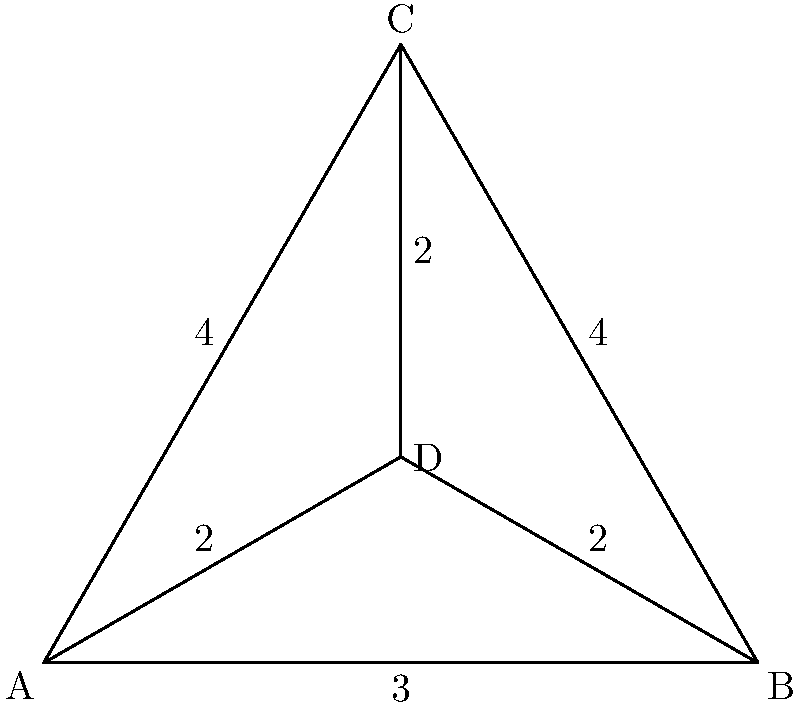As a patrol commander, you need to determine the most efficient route that covers all checkpoints in your area of responsibility. The diagram shows the network of checkpoints and the distances between them. What is the length of the shortest path that visits all checkpoints exactly once and returns to the starting point? To solve this problem, we need to find the Hamiltonian cycle with the shortest total length. This is known as the Traveling Salesman Problem. Let's approach this step-by-step:

1. Identify all possible Hamiltonian cycles:
   ABCDA, ACBDA, ABDCA, ACDBA, ADCBA, ADBCA

2. Calculate the length of each cycle:
   ABCDA: 3 + 4 + 2 + 2 = 11
   ACBDA: 4 + 4 + 2 + 2 = 12
   ABDCA: 3 + 2 + 2 + 4 = 11
   ACDBA: 4 + 2 + 2 + 3 = 11
   ADCBA: 2 + 2 + 4 + 3 = 11
   ADBCA: 2 + 2 + 4 + 4 = 12

3. Identify the shortest cycle(s):
   ABCDA, ABDCA, ACDBA, and ADCBA all have a length of 11, which is the shortest possible.

4. Verify that no shorter path exists:
   Since we've exhausted all possible Hamiltonian cycles and found multiple with length 11, we can conclude that 11 is indeed the length of the shortest path.

Therefore, the length of the shortest path that visits all checkpoints exactly once and returns to the starting point is 11 units.
Answer: 11 units 